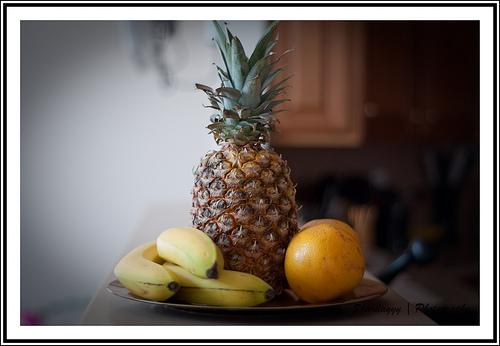With which fruit would be most connected to Costa Rica?

Choices:
A) orange
B) banana
C) pineapple
D) apple pineapple 